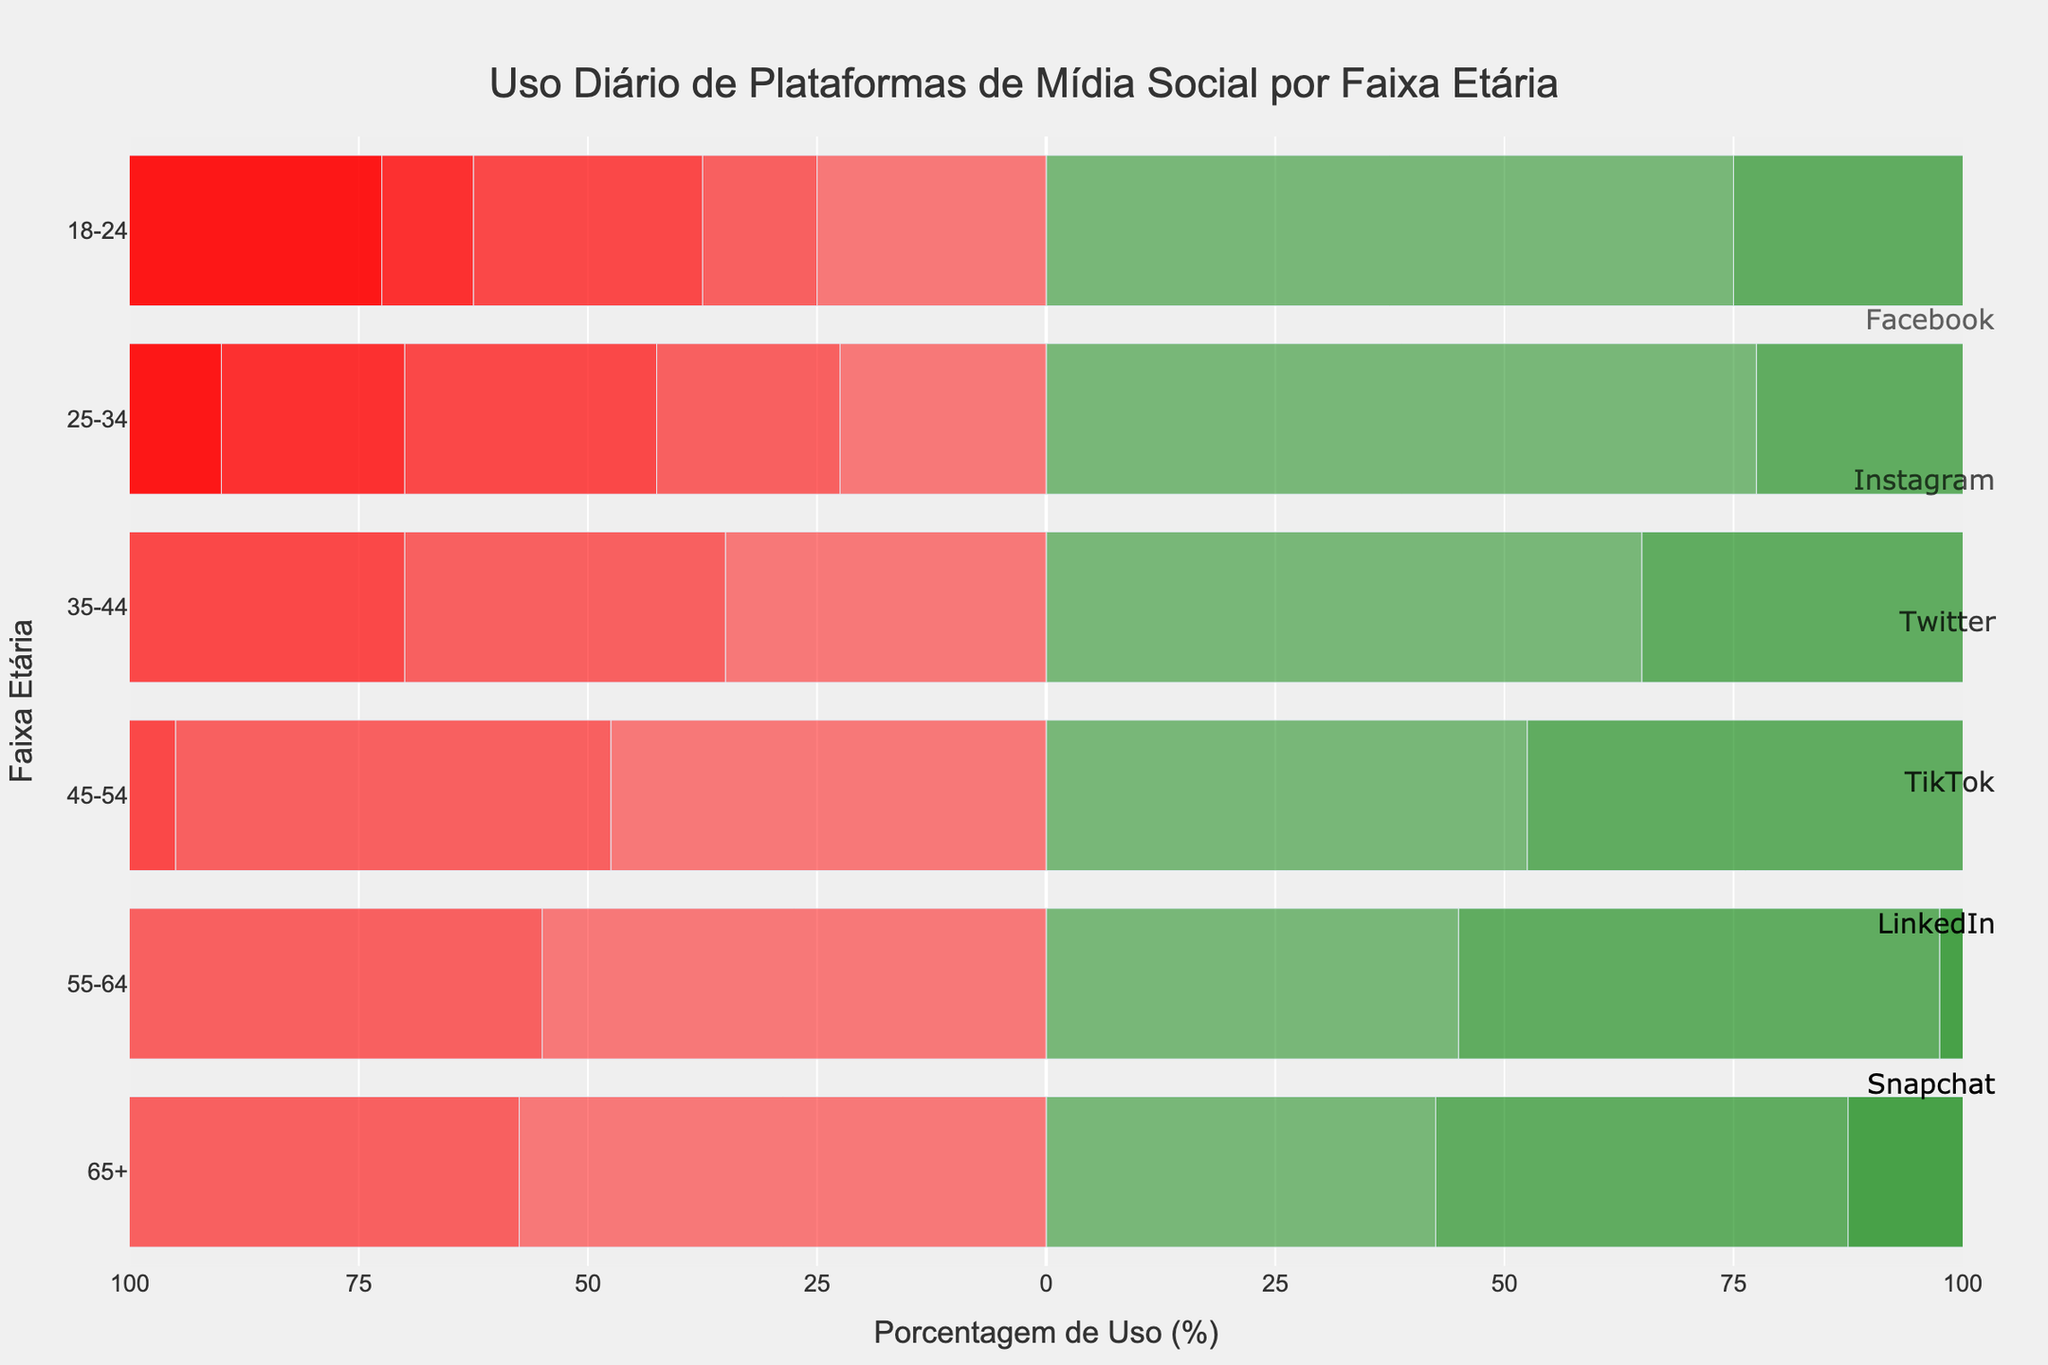What age group has the highest positive usage of TikTok? By looking at the TikTok positive bars, the age group 18-24 has the highest positive usage since their bar extends the furthest to the right.
Answer: 18-24 Which platform has the highest neutral usage for the age group 25-34? For the age group 25-34, compare the lengths of the neutral sections of the bars for each platform. The LinkedIn bar has a longer neutral section compared to other platforms.
Answer: LinkedIn What is the total usage (sum of positive, neutral, and negative) of Facebook for the age group 45-54? For Facebook in age group 45-54, the positive usage is 35%, the neutral usage is 35%, and the negative usage is 30%. Their sum is 35 + 35 + 30 = 100.
Answer: 100% Which platform and age group combination shows the highest negative usage? Compare the negative usage bars' lengths across platforms and age groups. The Facebook age group 65+ extends the furthest to the left, indicating it has the highest negative usage.
Answer: Facebook, 65+ What is the average positive usage for Instagram across all age groups? The positive usage for Instagram across the age groups is 80%, 70%, 50%, 35%, 40%, and 30%. Sum these values: 80 + 70 + 50 + 35 + 40 + 30 = 305. Divide by the six age groups: 305 / 6 = 50.83.
Answer: 50.83% Which platform shows a visually balanced usage (positive, neutral, and negative relatively equal) for any age group? By inspecting the bars, the 45-54 age group for Facebook shows a relatively balanced usage, with close lengths of all three sections: negative, neutral, and positive.
Answer: Facebook, 45-54 For the age group 18-24, which platform has the lowest neutral usage? Compare the neutral usage lengths for age group 18-24. By visually inspecting, TikTok has the shortest neutral section.
Answer: TikTok What is the difference in positive usage percentage between Instagram age group 18-24 and LinkedIn age group 25-34? Instagram age group 18-24 has a positive usage of 80%. LinkedIn age group 25-34 has a positive usage of 55%. The difference is 80 - 55 = 25.
Answer: 25% Which age group has the smallest visual negative usage for Snapchat? For Snapchat, compare the lengths of the negative bars across age groups. Age group 18-24 has the shortest negative section.
Answer: 18-24 